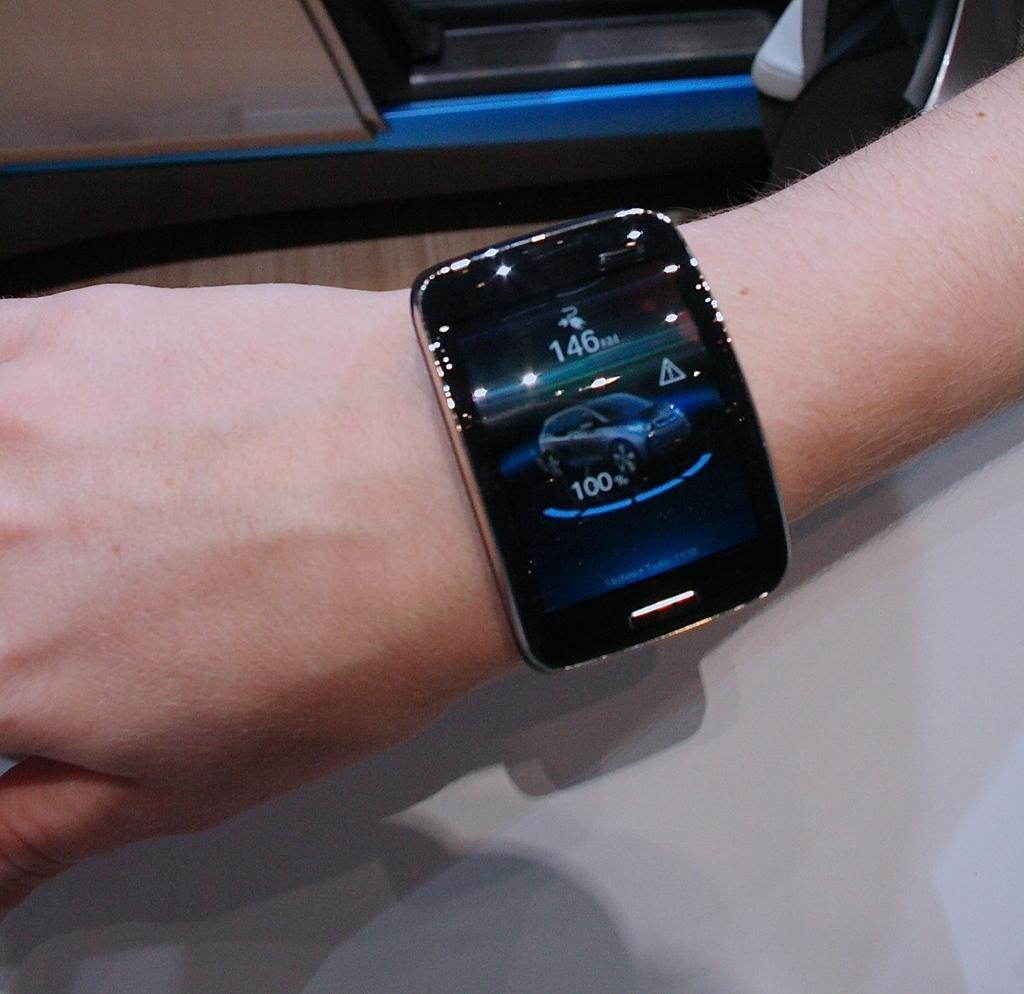<image>
Describe the image concisely. The numbers 146 and 100 are displayed around the image of a car on the face of a smartwatch. 